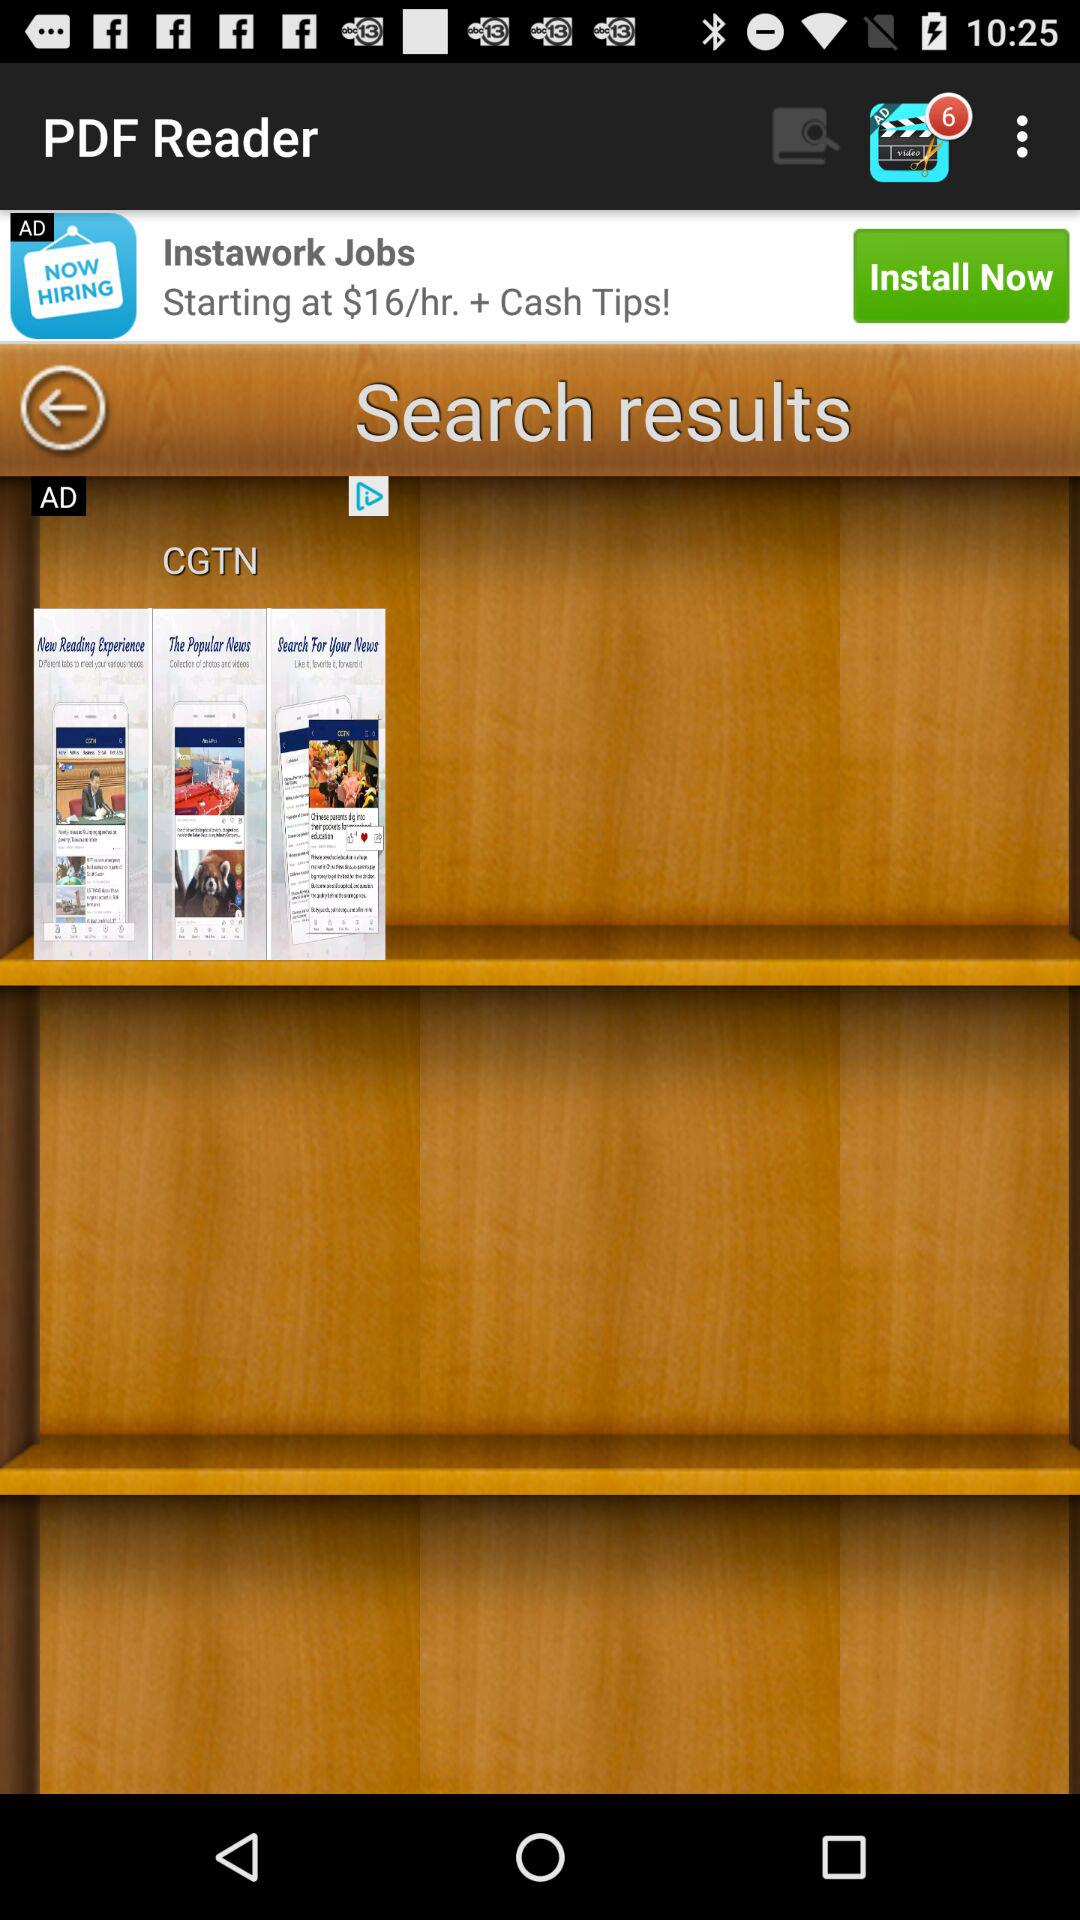What is the application name? The application name is "PDF Reader". 